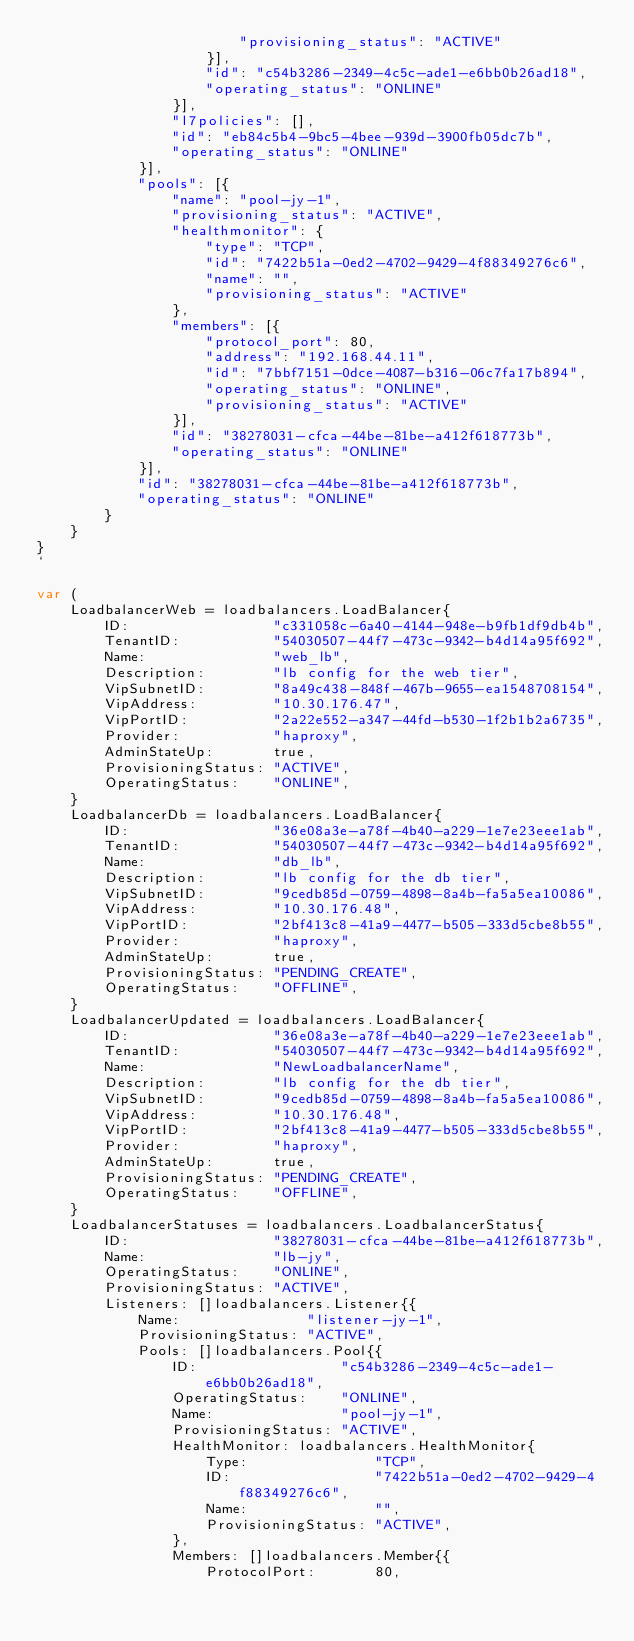Convert code to text. <code><loc_0><loc_0><loc_500><loc_500><_Go_>						"provisioning_status": "ACTIVE"
					}],
					"id": "c54b3286-2349-4c5c-ade1-e6bb0b26ad18",
					"operating_status": "ONLINE"
				}],
				"l7policies": [],
				"id": "eb84c5b4-9bc5-4bee-939d-3900fb05dc7b",
				"operating_status": "ONLINE"
			}],
			"pools": [{
				"name": "pool-jy-1",
				"provisioning_status": "ACTIVE",
				"healthmonitor": {
					"type": "TCP",
					"id": "7422b51a-0ed2-4702-9429-4f88349276c6",
					"name": "",
					"provisioning_status": "ACTIVE"
				},
				"members": [{
					"protocol_port": 80,
					"address": "192.168.44.11",
					"id": "7bbf7151-0dce-4087-b316-06c7fa17b894",
					"operating_status": "ONLINE",
					"provisioning_status": "ACTIVE"
				}],
				"id": "38278031-cfca-44be-81be-a412f618773b",
				"operating_status": "ONLINE"
			}],
			"id": "38278031-cfca-44be-81be-a412f618773b",
			"operating_status": "ONLINE"
		}
	}
}
`

var (
	LoadbalancerWeb = loadbalancers.LoadBalancer{
		ID:                 "c331058c-6a40-4144-948e-b9fb1df9db4b",
		TenantID:           "54030507-44f7-473c-9342-b4d14a95f692",
		Name:               "web_lb",
		Description:        "lb config for the web tier",
		VipSubnetID:        "8a49c438-848f-467b-9655-ea1548708154",
		VipAddress:         "10.30.176.47",
		VipPortID:          "2a22e552-a347-44fd-b530-1f2b1b2a6735",
		Provider:           "haproxy",
		AdminStateUp:       true,
		ProvisioningStatus: "ACTIVE",
		OperatingStatus:    "ONLINE",
	}
	LoadbalancerDb = loadbalancers.LoadBalancer{
		ID:                 "36e08a3e-a78f-4b40-a229-1e7e23eee1ab",
		TenantID:           "54030507-44f7-473c-9342-b4d14a95f692",
		Name:               "db_lb",
		Description:        "lb config for the db tier",
		VipSubnetID:        "9cedb85d-0759-4898-8a4b-fa5a5ea10086",
		VipAddress:         "10.30.176.48",
		VipPortID:          "2bf413c8-41a9-4477-b505-333d5cbe8b55",
		Provider:           "haproxy",
		AdminStateUp:       true,
		ProvisioningStatus: "PENDING_CREATE",
		OperatingStatus:    "OFFLINE",
	}
	LoadbalancerUpdated = loadbalancers.LoadBalancer{
		ID:                 "36e08a3e-a78f-4b40-a229-1e7e23eee1ab",
		TenantID:           "54030507-44f7-473c-9342-b4d14a95f692",
		Name:               "NewLoadbalancerName",
		Description:        "lb config for the db tier",
		VipSubnetID:        "9cedb85d-0759-4898-8a4b-fa5a5ea10086",
		VipAddress:         "10.30.176.48",
		VipPortID:          "2bf413c8-41a9-4477-b505-333d5cbe8b55",
		Provider:           "haproxy",
		AdminStateUp:       true,
		ProvisioningStatus: "PENDING_CREATE",
		OperatingStatus:    "OFFLINE",
	}
	LoadbalancerStatuses = loadbalancers.LoadbalancerStatus{
		ID:                 "38278031-cfca-44be-81be-a412f618773b",
		Name:               "lb-jy",
		OperatingStatus:    "ONLINE",
		ProvisioningStatus: "ACTIVE",
		Listeners: []loadbalancers.Listener{{
			Name:               "listener-jy-1",
			ProvisioningStatus: "ACTIVE",
			Pools: []loadbalancers.Pool{{
				ID:                 "c54b3286-2349-4c5c-ade1-e6bb0b26ad18",
				OperatingStatus:    "ONLINE",
				Name:               "pool-jy-1",
				ProvisioningStatus: "ACTIVE",
				HealthMonitor: loadbalancers.HealthMonitor{
					Type:               "TCP",
					ID:                 "7422b51a-0ed2-4702-9429-4f88349276c6",
					Name:               "",
					ProvisioningStatus: "ACTIVE",
				},
				Members: []loadbalancers.Member{{
					ProtocolPort:       80,</code> 